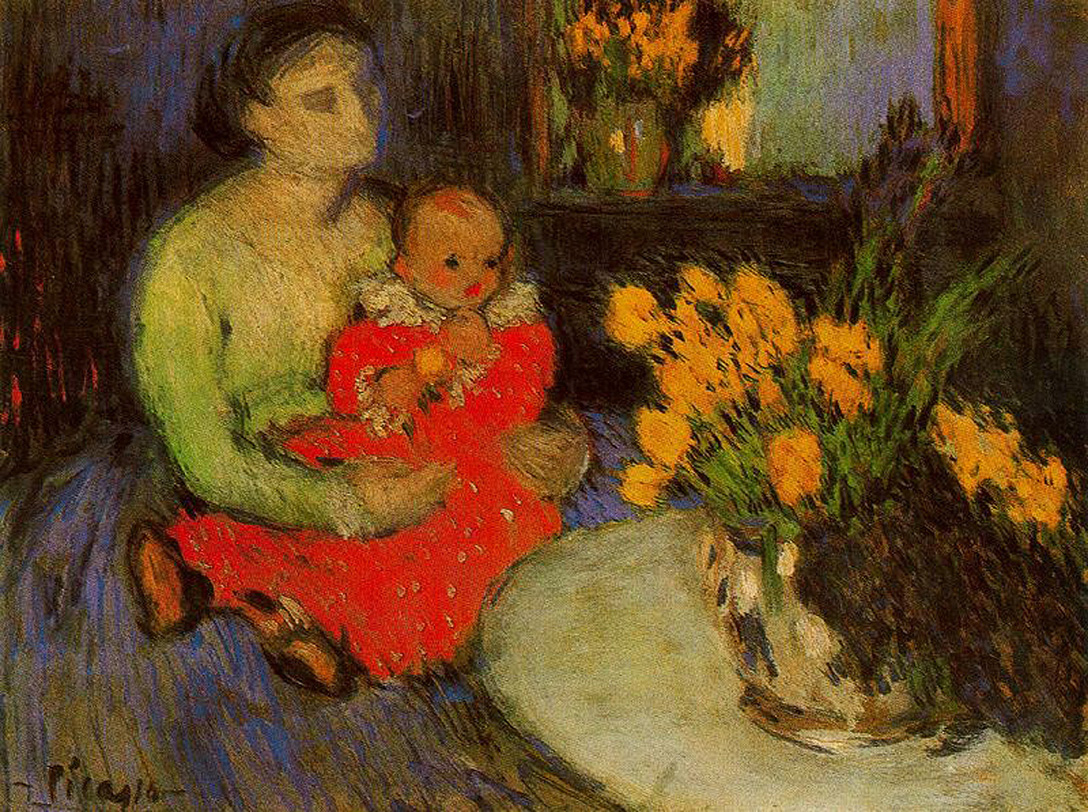Imagine a story behind this painting. What could be the background for this tender moment? In a quaint, dimly lit room filled with the scent of fresh flowers, a mother and her child share a quiet moment of solace and love. The mother, having spent the day tending to the household, finally gets a moment to rest and cuddle her child. The child, curious and full of energy, plays with a small toy in their hand, while the mother hums a soft lullaby. The vase of flowers on the table, picked from their garden that morning, nod gently with the breeze coming through the slightly open window. This peaceful moment is a brief respite from the day’s demands, capturing the essence of maternal love and the simple joys of family life. What season do you think it is and why do you suppose so? Given the warm and vibrant colors of the flowers and the overall coziness of the scene, it’s likely that the season is spring. Spring is often associated with renewal, warmth, and blooming flowers, which aligns with the bright and lively floral arrangement in the painting. The earthy tones and textures used by the artist also convey a sense of warmth and new beginnings, common sentiments tied to springtime. 